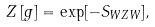<formula> <loc_0><loc_0><loc_500><loc_500>Z \left [ g \right ] = \exp [ - S _ { W Z W } ] ,</formula> 